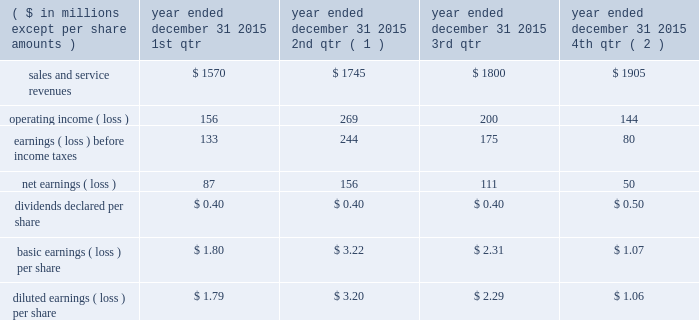Of exercise for stock options exercised or at period end for outstanding stock options , less the applicable exercise price .
The company issued new shares to satisfy exercised stock options .
Compensation expense the company recorded $ 43 million , $ 34 million , and $ 44 million of expense related to stock awards for the years ended december 31 , 2015 , 2014 , and 2013 , respectively .
The company recorded $ 17 million , $ 13 million , and $ 17 million as a tax benefit related to stock awards and stock options for the years ended december 31 , 2015 , 2014 , and 2013 , respectively .
The company recognized tax benefits for the years ended december 31 , 2015 , 2014 , and 2013 , of $ 41 million , $ 53 million , and $ 32 million , respectively , from the issuance of stock in settlement of stock awards , and $ 4 million , $ 5 million , and $ 4 million for the years ended december 31 , 2015 , 2014 , and 2013 , respectively , from the exercise of stock options .
Unrecognized compensation expense as of december 31 , 2015 , the company had less than $ 1 million of unrecognized compensation expense associated with rsrs granted in 2015 and 2014 , which will be recognized over a weighted average period of 1.0 year , and $ 25 million of unrecognized expense associated with rpsrs granted in 2015 , 2014 , and 2013 , which will be recognized over a weighted average period of 0.6 years .
As of december 31 , 2015 , the company had no unrecognized compensation expense related to stock options .
Compensation expense for stock options was fully recognized as of december 31 , 2013 .
20 .
Unaudited selected quarterly data unaudited quarterly financial results for the years ended december 31 , 2015 and 2014 , are set forth in the tables: .
( 1 ) in the second quarter of 2015 , the company recorded a $ 59 million goodwill impairment charge .
During the same period , the company recorded $ 136 million of operating income as a result of the aon settlement .
( 2 ) in the fourth quarter of 2015 , the company recorded $ 16 million goodwill impairment and $ 27 million intangible asset impairment charges. .
What is the total net income for the fiscal year of 2015? 
Computations: (((87 + 156) + 111) + 50)
Answer: 404.0. 